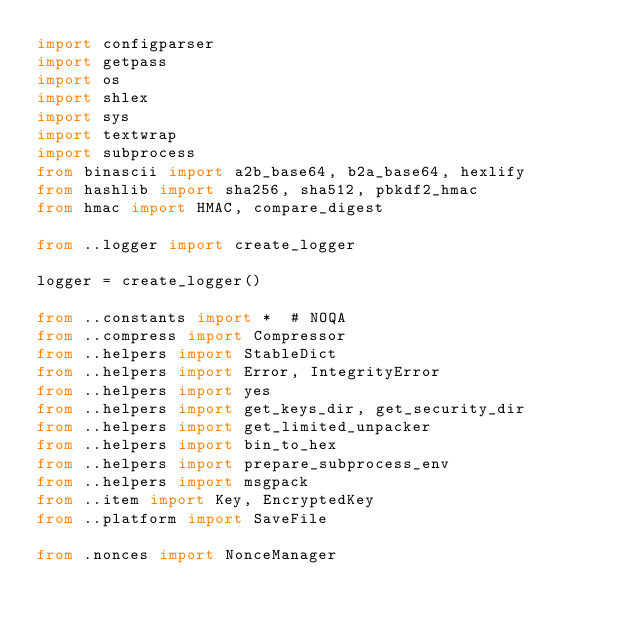Convert code to text. <code><loc_0><loc_0><loc_500><loc_500><_Python_>import configparser
import getpass
import os
import shlex
import sys
import textwrap
import subprocess
from binascii import a2b_base64, b2a_base64, hexlify
from hashlib import sha256, sha512, pbkdf2_hmac
from hmac import HMAC, compare_digest

from ..logger import create_logger

logger = create_logger()

from ..constants import *  # NOQA
from ..compress import Compressor
from ..helpers import StableDict
from ..helpers import Error, IntegrityError
from ..helpers import yes
from ..helpers import get_keys_dir, get_security_dir
from ..helpers import get_limited_unpacker
from ..helpers import bin_to_hex
from ..helpers import prepare_subprocess_env
from ..helpers import msgpack
from ..item import Key, EncryptedKey
from ..platform import SaveFile

from .nonces import NonceManager</code> 